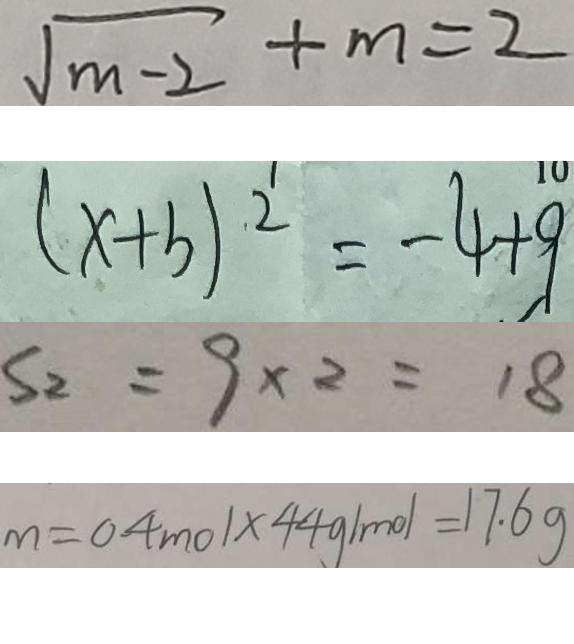Convert formula to latex. <formula><loc_0><loc_0><loc_500><loc_500>\sqrt { m - 2 } + m = 2 
 ( x + b ) ^ { 2 } = - 4 + 9 
 S _ { 2 } = 9 \times 2 = 1 8 
 m = 0 . 4 m o l \times 4 4 g / m o l = 1 7 . 6 g</formula> 